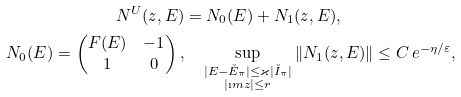<formula> <loc_0><loc_0><loc_500><loc_500>N ^ { U } ( z , E ) & = N _ { 0 } ( E ) + N _ { 1 } ( z , E ) , \\ \quad N _ { 0 } ( E ) = \begin{pmatrix} F ( E ) & - 1 \\ 1 & 0 \end{pmatrix} , & \quad \sup _ { \substack { | E - \check { E } _ { \pi } | \leq \varkappa | \check { I } _ { \pi } | \\ | \i m z | \leq r } } \| N _ { 1 } ( z , E ) \| \leq C \, e ^ { - \eta / \varepsilon } ,</formula> 